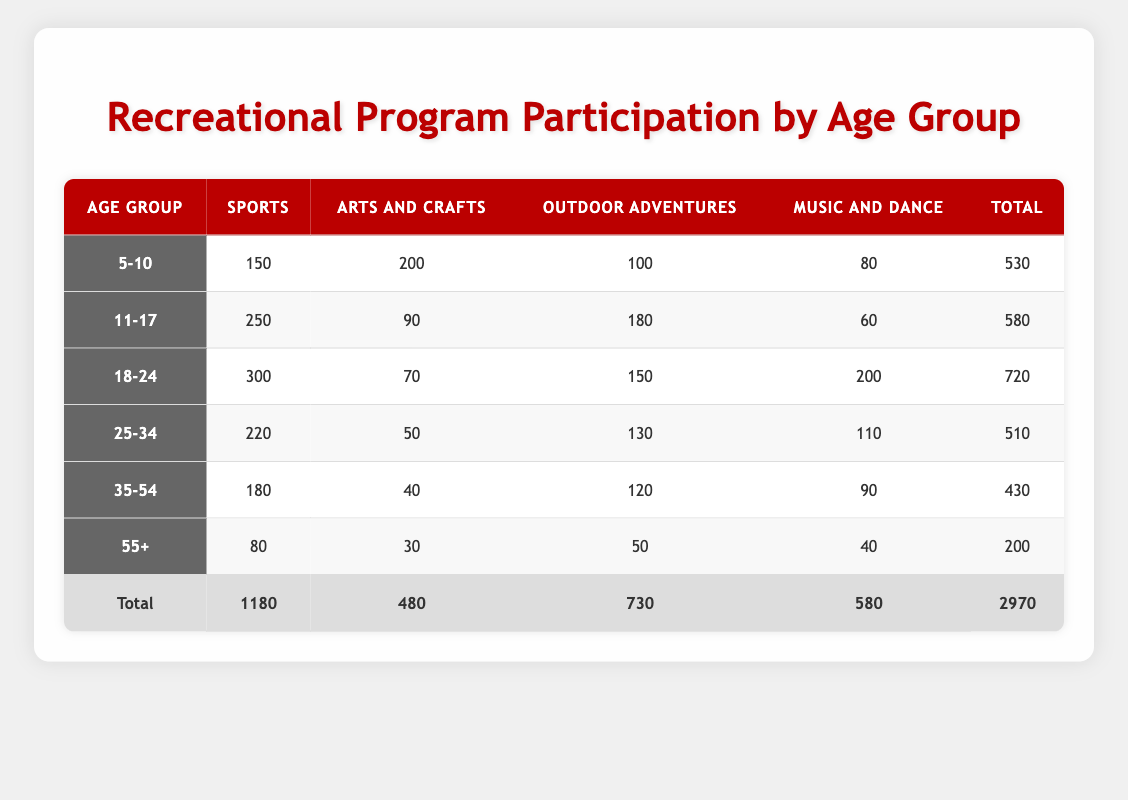What age group has the highest participation in Sports? Looking at the "Sports" column, the highest number of participants is 300 in the "18-24" age group.
Answer: 18-24 How many participants are involved in Arts and Crafts in the 35-54 age group? Referring to the "Arts and Crafts" column for the "35-54" age group, there are 40 participants.
Answer: 40 What is the total participation across all programs for the "55+" age group? Summing the numbers from the "55+" age group: 80 (Sports) + 30 (Arts and Crafts) + 50 (Outdoor Adventures) + 40 (Music and Dance) gives us 200 total participants.
Answer: 200 Is the total participation for the "25-34" age group greater than 500? The total for the "25-34" age group is 510, which is greater than 500, making this statement true.
Answer: Yes What is the average participation in Outdoor Adventures across all age groups? We sum the participants in Outdoor Adventures: 100 + 180 + 150 + 130 + 120 + 50 = 730. There are 6 age groups, so the average is 730/6 = approximately 121.67.
Answer: Approximately 121.67 Which age group has the lowest total participants? The totals for each age group are: 530, 580, 720, 510, 430, and 200. The lowest total is 200 in the "55+" age group.
Answer: 55+ How many more people participated in Music and Dance compared to Arts and Crafts in the "18-24" age group? Looking at the "18-24" age group, there are 200 participants in Music and Dance and 70 in Arts and Crafts. Calculating the difference: 200 - 70 = 130 participants more in Music and Dance.
Answer: 130 Is it true that the total number of participants in Sports is greater than the total in Music and Dance? The total participants in Sports is 1180, and in Music and Dance, it is 580. Since 1180 is greater than 580, this statement is true.
Answer: Yes 